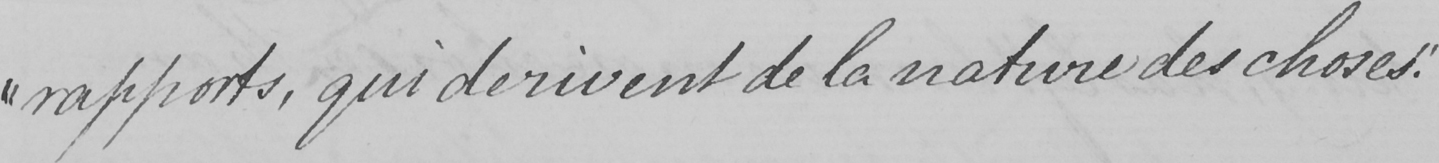What is written in this line of handwriting? " rapports , qui derivent de la nature des choses . " 